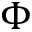<formula> <loc_0><loc_0><loc_500><loc_500>\Phi</formula> 